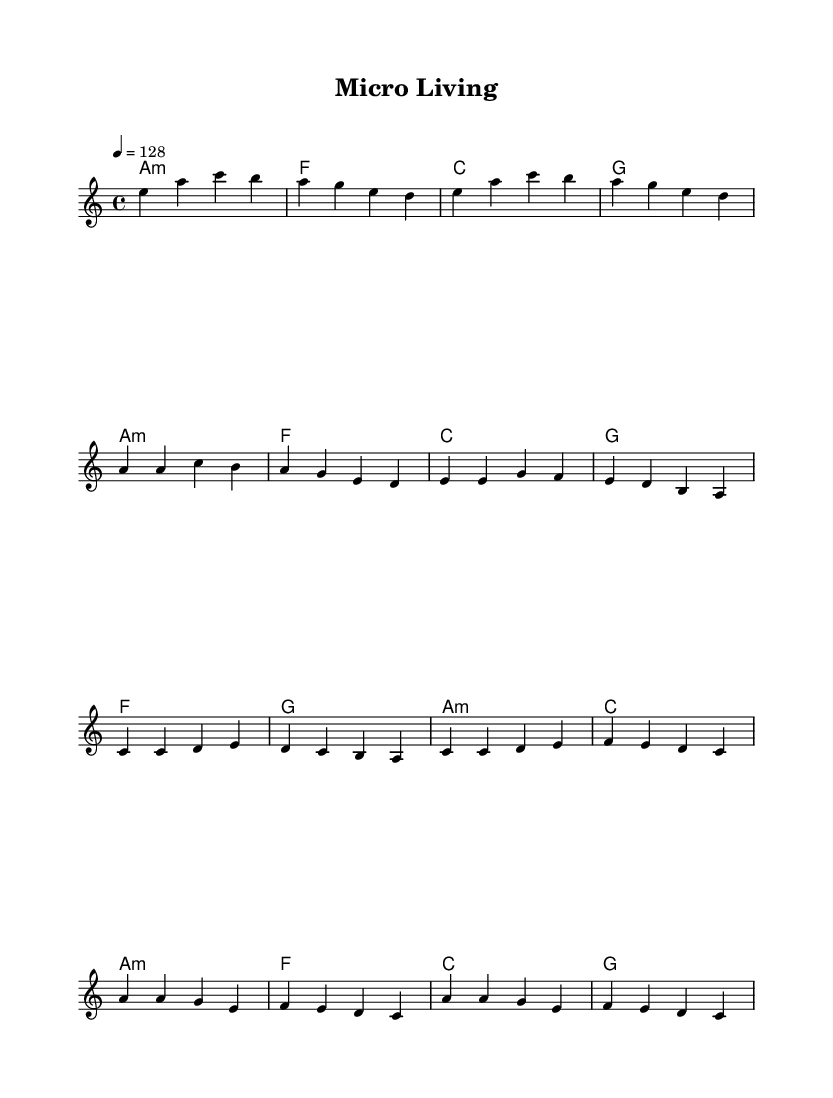What is the key signature of this music? The key signature is A minor, indicated by the absence of sharps or flats on the staff.
Answer: A minor What is the time signature of this music? The time signature is 4/4, which is shown at the beginning of the sheet music as the fraction indicating four beats per measure and a quarter note gets one beat.
Answer: 4/4 What is the tempo marking in this music? The tempo marking is 4 equals 128, suggesting that there are 128 beats per minute, which is noted at the beginning of the sheet music.
Answer: 128 How many measures are there in the chorus section? The chorus section consists of four measures, identified by the repeat of the pattern labeled "Chorus" in the sheet music.
Answer: Four Which chord is played during the Pre-Chorus? The first chord in the Pre-Chorus is F major, as indicated in the chord progression under the corresponding section.
Answer: F What is the role of synthesizers in K-Pop music? Synthesizers are typically used for creating rich textural layers, driving rhythms, and catchy melodic hooks, aligning with the genre's pop appeal and electronic influences.
Answer: Textures What is the structure of this piece? The structure follows an Intro, Verse, Pre-Chorus, and Chorus format, a common arrangement in K-Pop songs for building tension and release throughout the music.
Answer: Intro, Verse, Pre-Chorus, Chorus 